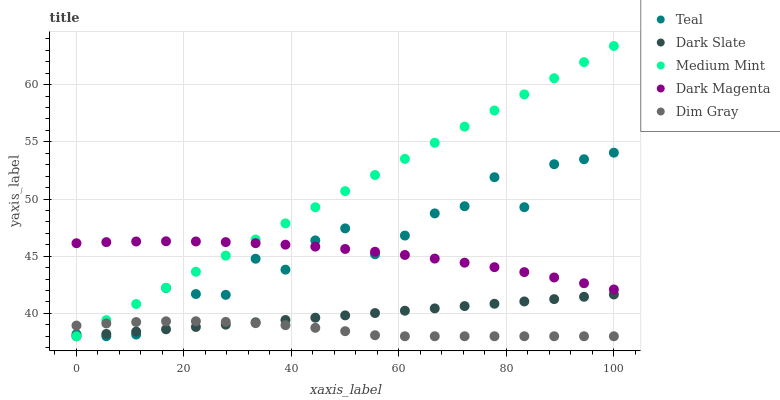Does Dim Gray have the minimum area under the curve?
Answer yes or no. Yes. Does Medium Mint have the maximum area under the curve?
Answer yes or no. Yes. Does Dark Slate have the minimum area under the curve?
Answer yes or no. No. Does Dark Slate have the maximum area under the curve?
Answer yes or no. No. Is Dark Slate the smoothest?
Answer yes or no. Yes. Is Teal the roughest?
Answer yes or no. Yes. Is Dim Gray the smoothest?
Answer yes or no. No. Is Dim Gray the roughest?
Answer yes or no. No. Does Medium Mint have the lowest value?
Answer yes or no. Yes. Does Dark Magenta have the lowest value?
Answer yes or no. No. Does Medium Mint have the highest value?
Answer yes or no. Yes. Does Dark Slate have the highest value?
Answer yes or no. No. Is Dim Gray less than Dark Magenta?
Answer yes or no. Yes. Is Dark Magenta greater than Dim Gray?
Answer yes or no. Yes. Does Dim Gray intersect Medium Mint?
Answer yes or no. Yes. Is Dim Gray less than Medium Mint?
Answer yes or no. No. Is Dim Gray greater than Medium Mint?
Answer yes or no. No. Does Dim Gray intersect Dark Magenta?
Answer yes or no. No. 